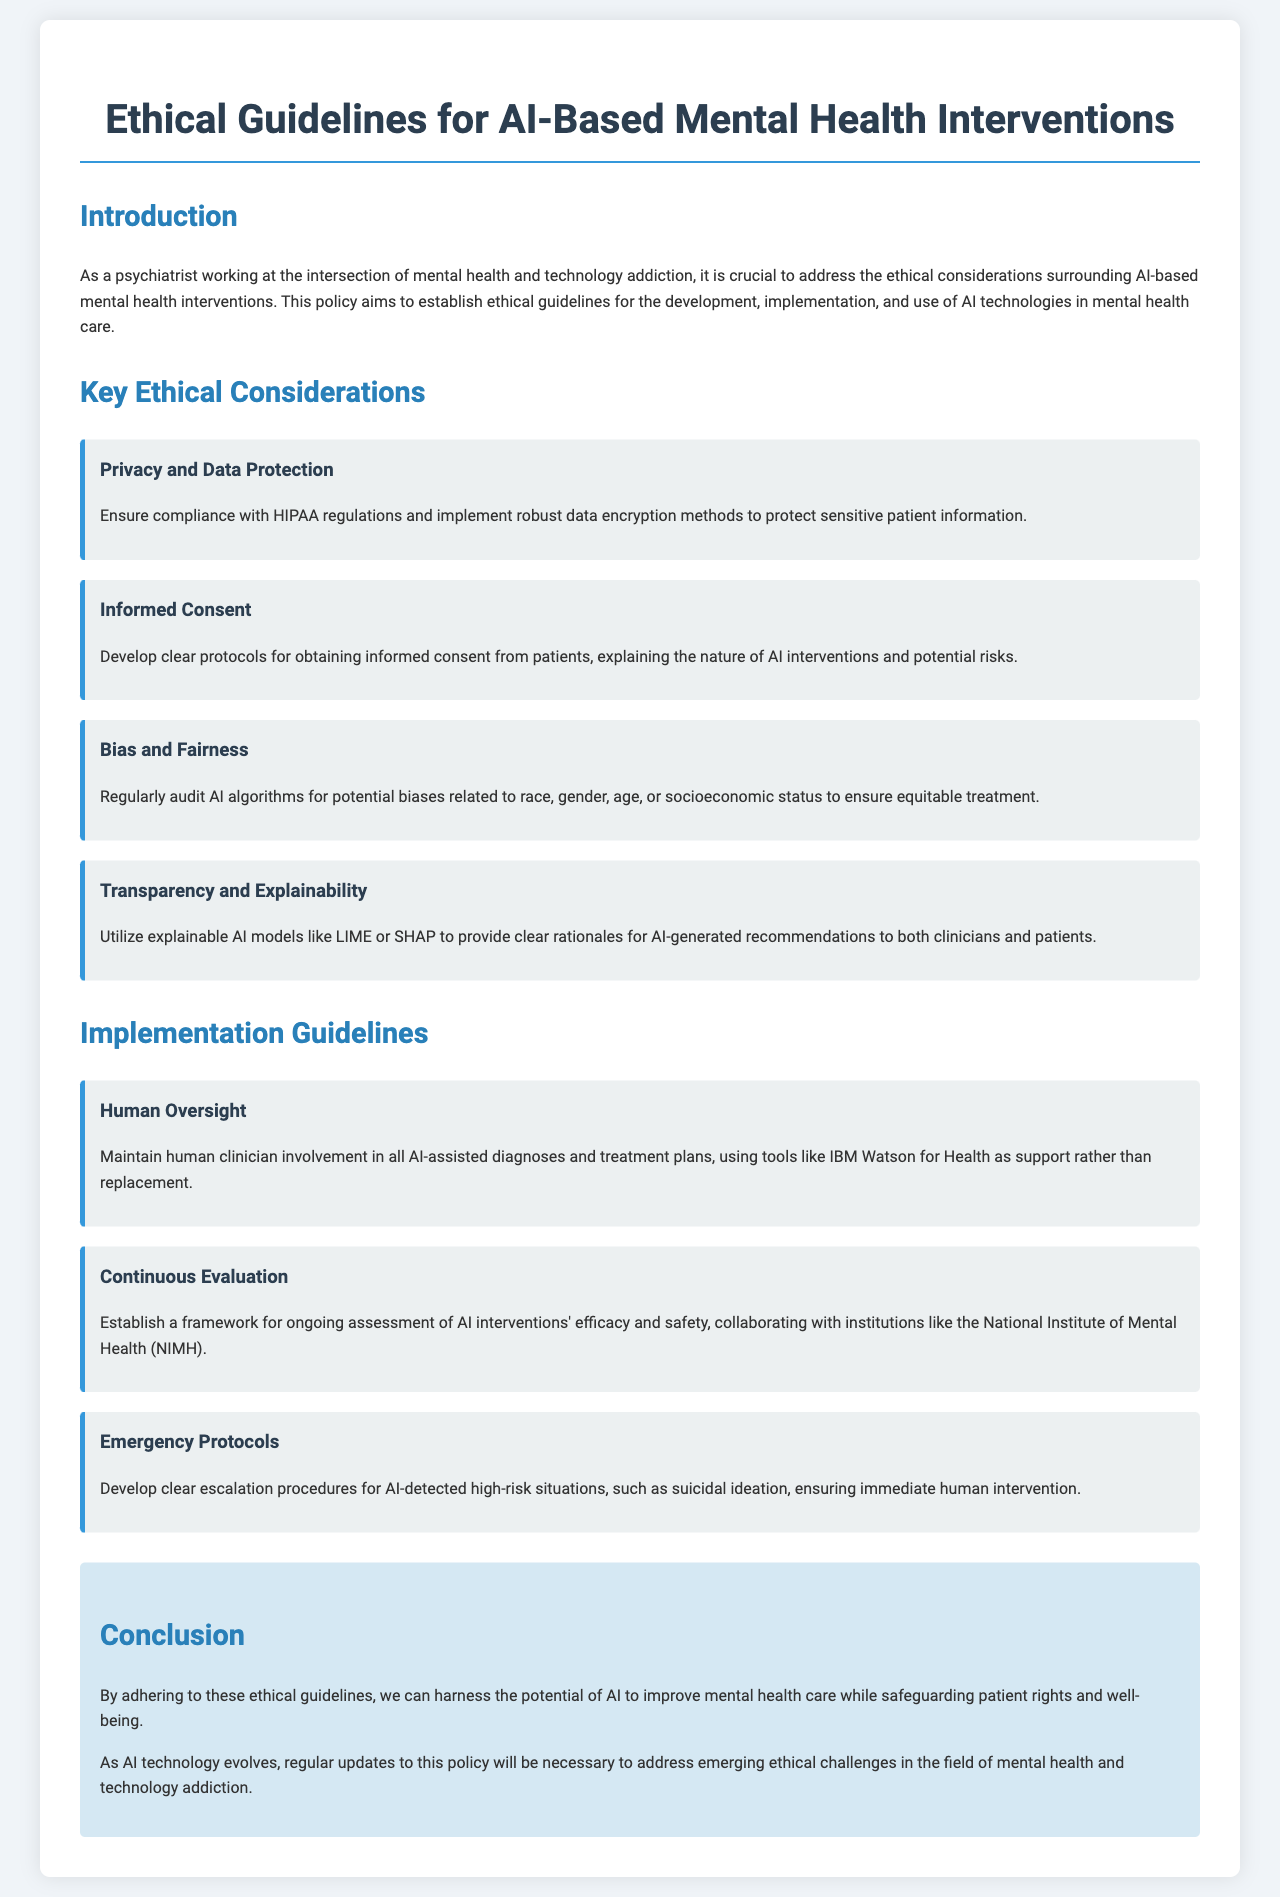What is the title of the document? The title of the document is stated in the heading at the top of the rendered content.
Answer: Ethical Guidelines for AI-Based Mental Health Interventions What is the first ethical consideration listed? The first ethical consideration is found in the section that enumerates key ethical considerations.
Answer: Privacy and Data Protection Which AI models are recommended for explainability? The names of the AI models are mentioned specifically in the section addressing explainability of AI.
Answer: LIME or SHAP What is required for informed consent? The requirements for informed consent are described in the section dedicated to this ethical consideration.
Answer: Clear protocols How often should AI algorithms be audited for bias? Auditing of AI algorithms for bias is mentioned in the document, implying a regular interval.
Answer: Regularly What is the purpose of human oversight in AI interventions? The role of human oversight is explained in the guidelines for implementation of AI technologies in mental health care.
Answer: Support rather than replacement What should be developed for high-risk situations identified by AI? The document discusses the necessary protocols established for high-risk situations detected by AI.
Answer: Clear escalation procedures Which organization is recommended for collaboration to evaluate AI interventions? The organization mentioned for collaboration on ongoing assessment of AI interventions is identified in the context of evaluation.
Answer: National Institute of Mental Health (NIMH) What must be done to keep the guidelines up-to-date? The conclusion specifies an action plan regarding the guidelines in relation to evolving AI technology.
Answer: Regular updates 